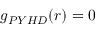Convert formula to latex. <formula><loc_0><loc_0><loc_500><loc_500>g _ { P Y H D } ( r ) = 0</formula> 